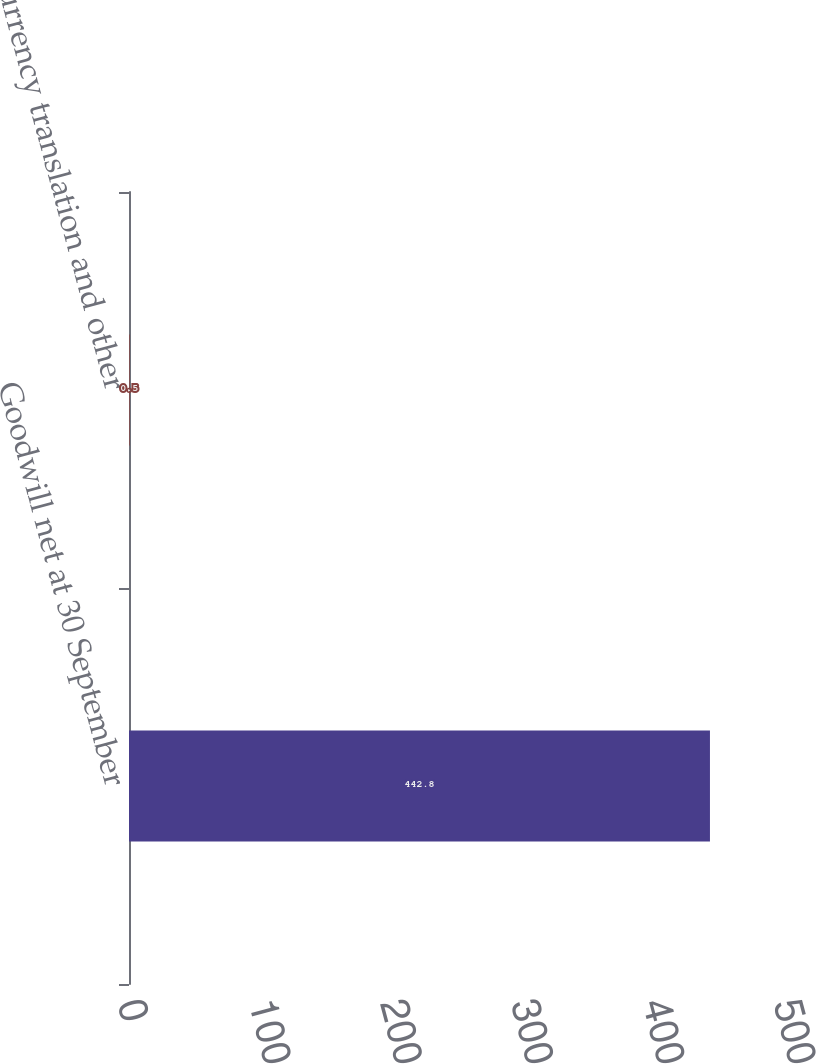<chart> <loc_0><loc_0><loc_500><loc_500><bar_chart><fcel>Goodwill net at 30 September<fcel>Currency translation and other<nl><fcel>442.8<fcel>0.5<nl></chart> 